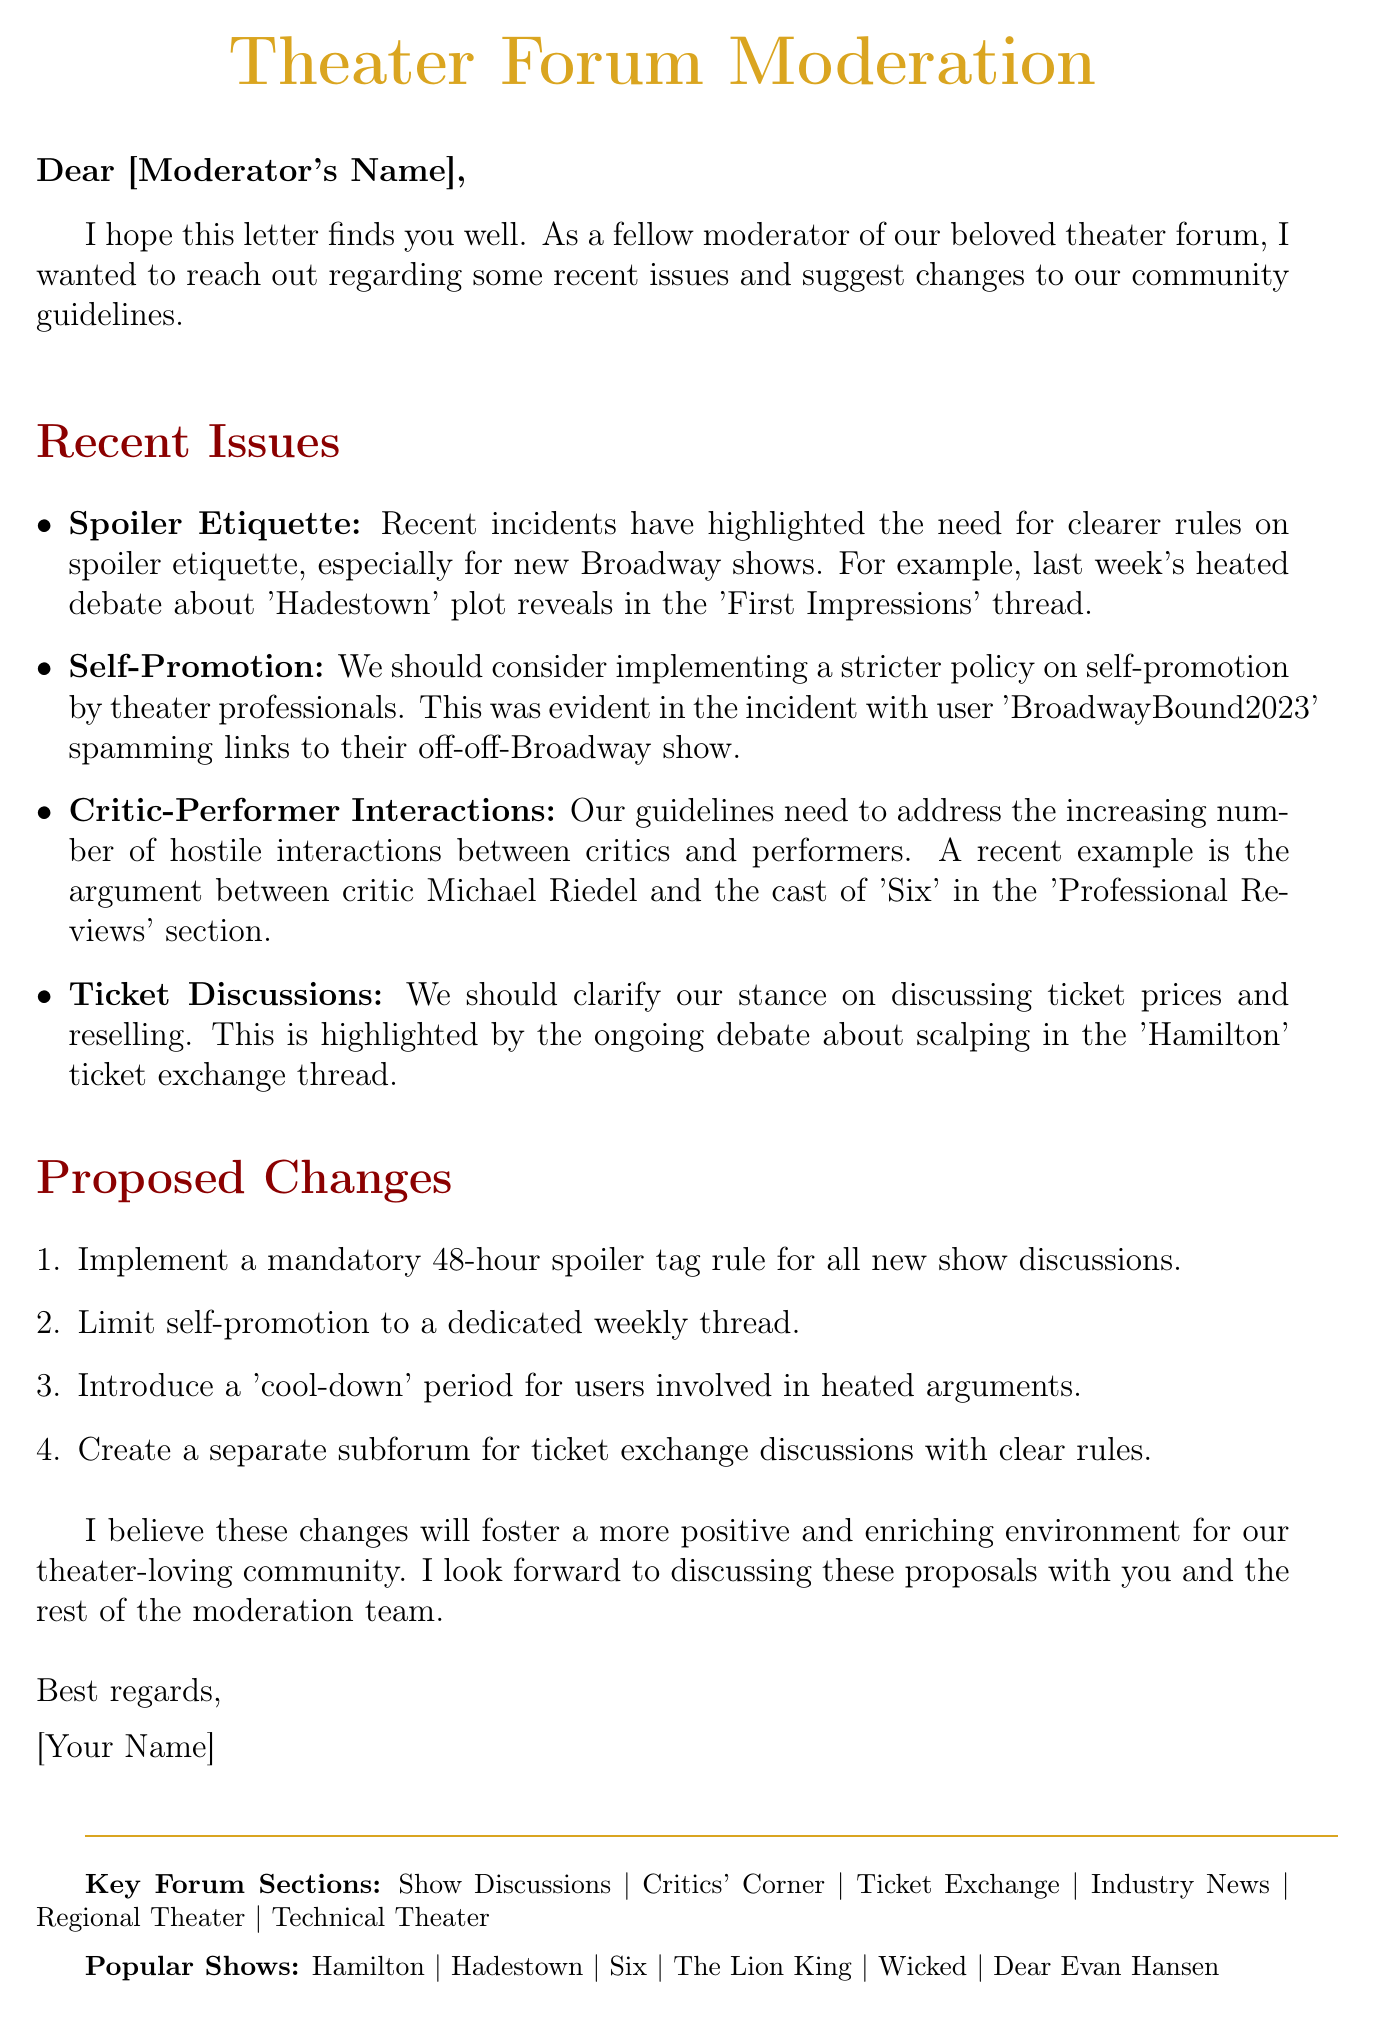what is the first proposed change in the letter? The first proposed change is listed in the 'Proposed Changes' section.
Answer: Implement a mandatory 48-hour spoiler tag rule for all new show discussions who wrote the letter? The author's name would be at the end of the letter, indicated as [Your Name].
Answer: [Your Name] what is one recent controversy mentioned in the letter? The letter cites recent controversies and a few examples are given in 'Recent Issues'.
Answer: Debate over gender-blind casting in 'Company' revival which user is associated with self-promotion issues? The letter provides a specific example of a user involved in self-promotion problems.
Answer: BroadwayBound2023 what should be limited to a dedicated weekly thread according to the letter? This is specified as part of the proposed changes in the body of the letter.
Answer: Self-promotion by theater professionals what does the author suggest to address heated arguments? This suggestion can be found in the 'Proposed Changes' section where cooling-off measures are discussed.
Answer: Introduce a 'cool-down' period for users involved in heated arguments which section discusses ticket prices and reselling? The letter indicates the need for clarification on this topic in the 'Recent Issues' section.
Answer: Ticket Discussions how many key forum sections are listed at the bottom of the document? This is a part of the footer information of the letter.
Answer: Six 